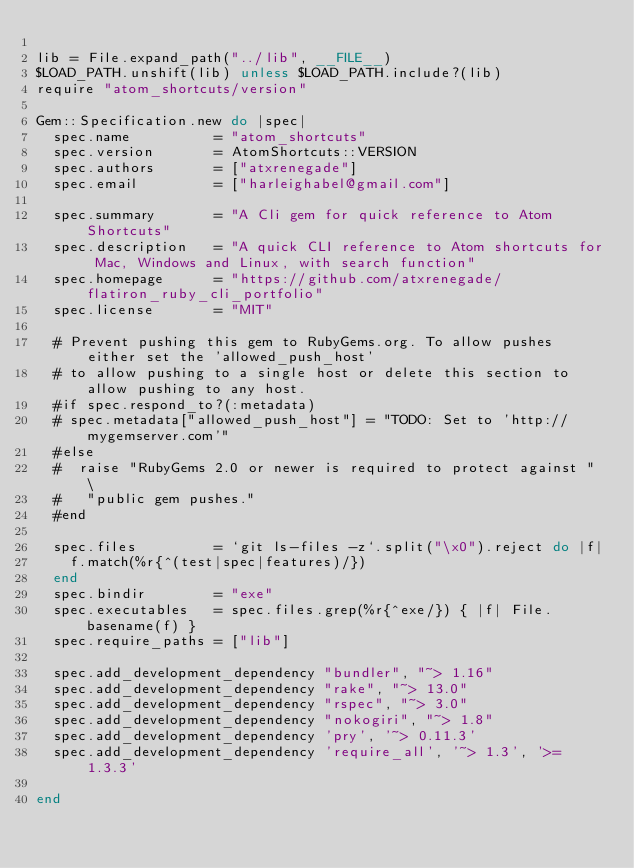<code> <loc_0><loc_0><loc_500><loc_500><_Ruby_>
lib = File.expand_path("../lib", __FILE__)
$LOAD_PATH.unshift(lib) unless $LOAD_PATH.include?(lib)
require "atom_shortcuts/version"

Gem::Specification.new do |spec|
  spec.name          = "atom_shortcuts"
  spec.version       = AtomShortcuts::VERSION
  spec.authors       = ["atxrenegade"]
  spec.email         = ["harleighabel@gmail.com"]

  spec.summary       = "A Cli gem for quick reference to Atom Shortcuts"
  spec.description   = "A quick CLI reference to Atom shortcuts for Mac, Windows and Linux, with search function"
  spec.homepage      = "https://github.com/atxrenegade/flatiron_ruby_cli_portfolio"
  spec.license       = "MIT"

  # Prevent pushing this gem to RubyGems.org. To allow pushes either set the 'allowed_push_host'
  # to allow pushing to a single host or delete this section to allow pushing to any host.
  #if spec.respond_to?(:metadata)
  # spec.metadata["allowed_push_host"] = "TODO: Set to 'http://mygemserver.com'"
  #else
  #  raise "RubyGems 2.0 or newer is required to protect against " \
  #   "public gem pushes."
  #end

  spec.files         = `git ls-files -z`.split("\x0").reject do |f|
    f.match(%r{^(test|spec|features)/})
  end
  spec.bindir        = "exe"
  spec.executables   = spec.files.grep(%r{^exe/}) { |f| File.basename(f) }
  spec.require_paths = ["lib"]

  spec.add_development_dependency "bundler", "~> 1.16"
  spec.add_development_dependency "rake", "~> 13.0"
  spec.add_development_dependency "rspec", "~> 3.0"
  spec.add_development_dependency "nokogiri", "~> 1.8"
  spec.add_development_dependency 'pry', '~> 0.11.3'
  spec.add_development_dependency 'require_all', '~> 1.3', '>= 1.3.3'

end
</code> 